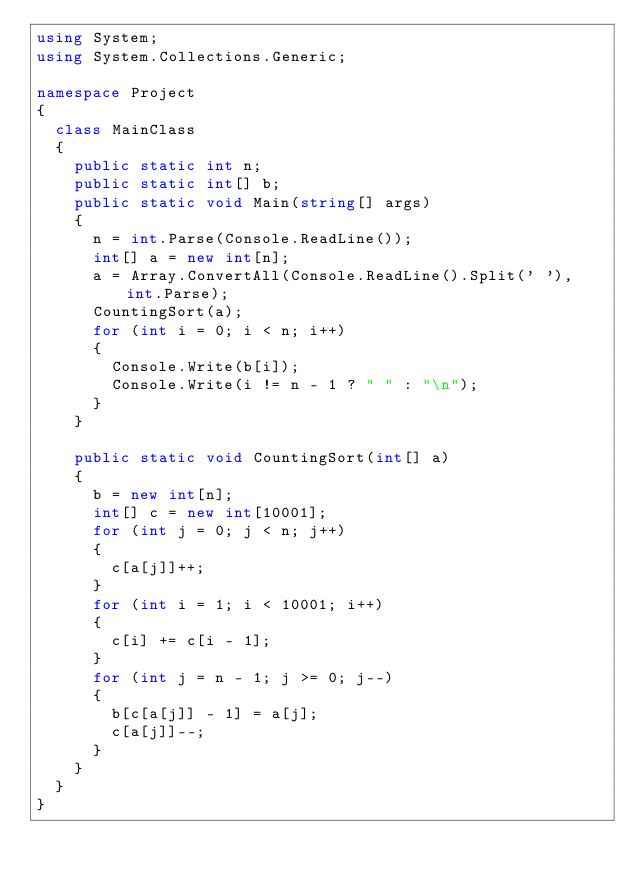Convert code to text. <code><loc_0><loc_0><loc_500><loc_500><_C#_>using System;
using System.Collections.Generic;

namespace Project
{
	class MainClass
	{
		public static int n;
		public static int[] b;
		public static void Main(string[] args)
		{
			n = int.Parse(Console.ReadLine());
			int[] a = new int[n];
			a = Array.ConvertAll(Console.ReadLine().Split(' '), int.Parse);
			CountingSort(a);
			for (int i = 0; i < n; i++)
			{
				Console.Write(b[i]);
				Console.Write(i != n - 1 ? " " : "\n");
			}
		}

		public static void CountingSort(int[] a)
		{
			b = new int[n];
			int[] c = new int[10001];
			for (int j = 0; j < n; j++)
			{
				c[a[j]]++;
			}
			for (int i = 1; i < 10001; i++)
			{
				c[i] += c[i - 1];
			}
			for (int j = n - 1; j >= 0; j--)
			{
				b[c[a[j]] - 1] = a[j];
				c[a[j]]--;
			}
		}
	}
}</code> 